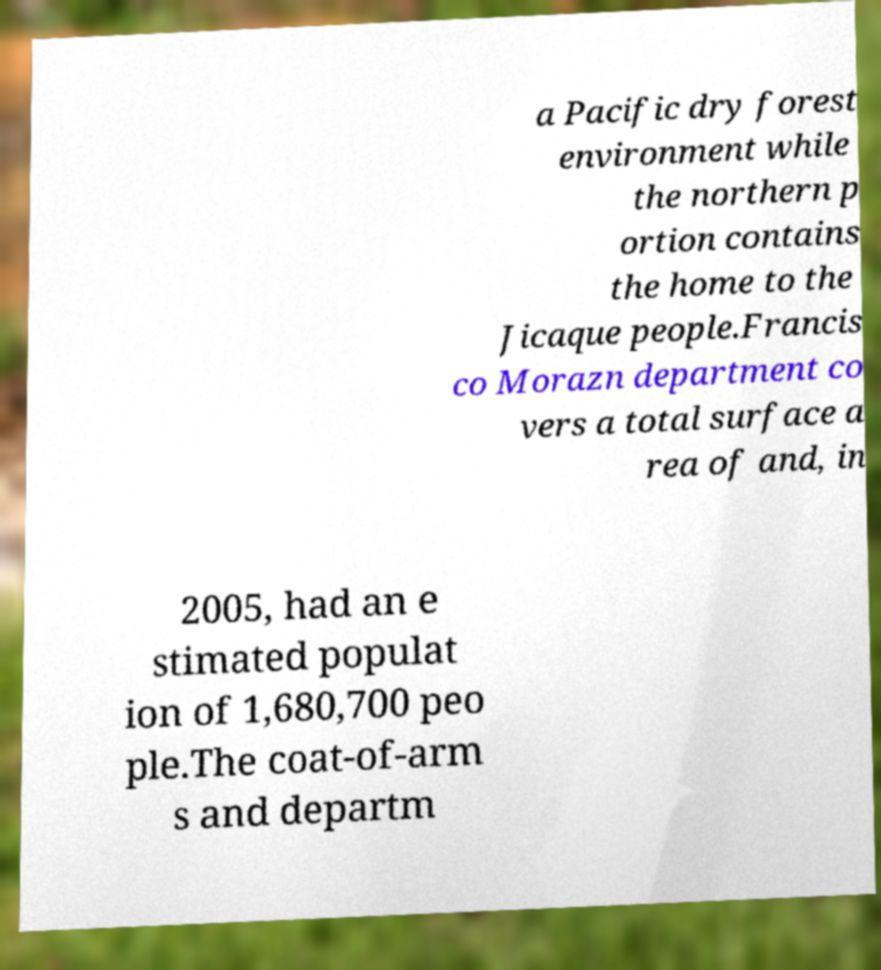Can you read and provide the text displayed in the image?This photo seems to have some interesting text. Can you extract and type it out for me? a Pacific dry forest environment while the northern p ortion contains the home to the Jicaque people.Francis co Morazn department co vers a total surface a rea of and, in 2005, had an e stimated populat ion of 1,680,700 peo ple.The coat-of-arm s and departm 